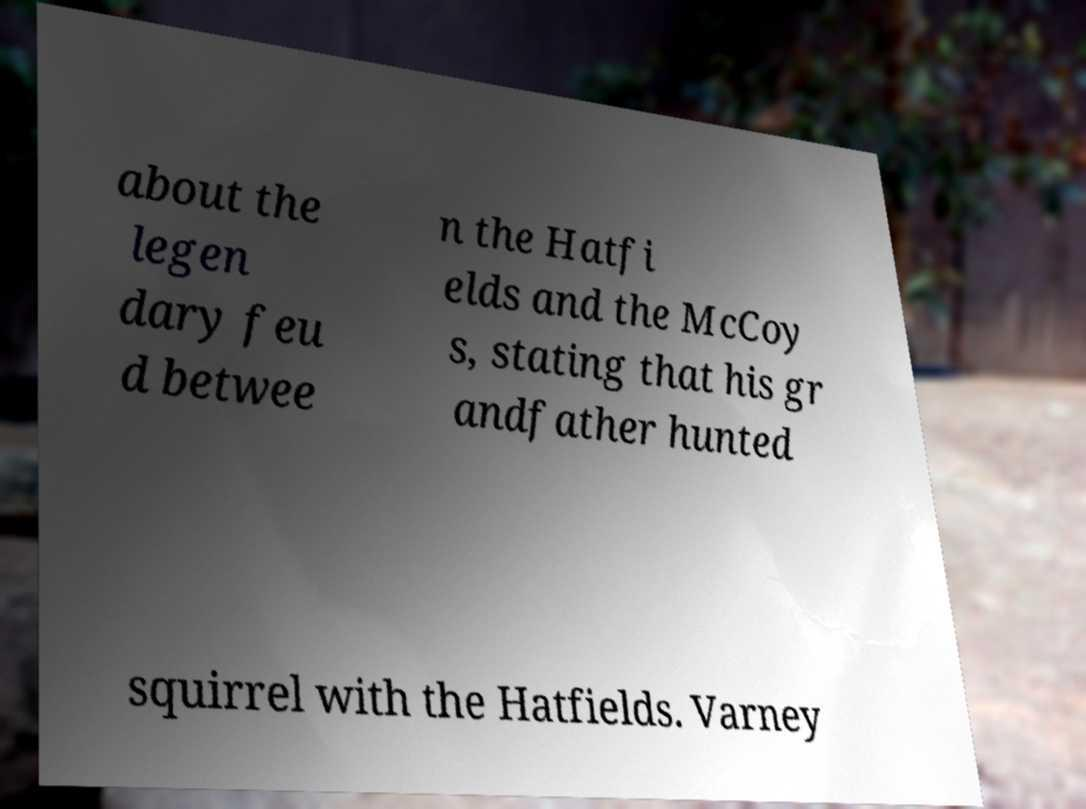Please identify and transcribe the text found in this image. about the legen dary feu d betwee n the Hatfi elds and the McCoy s, stating that his gr andfather hunted squirrel with the Hatfields. Varney 